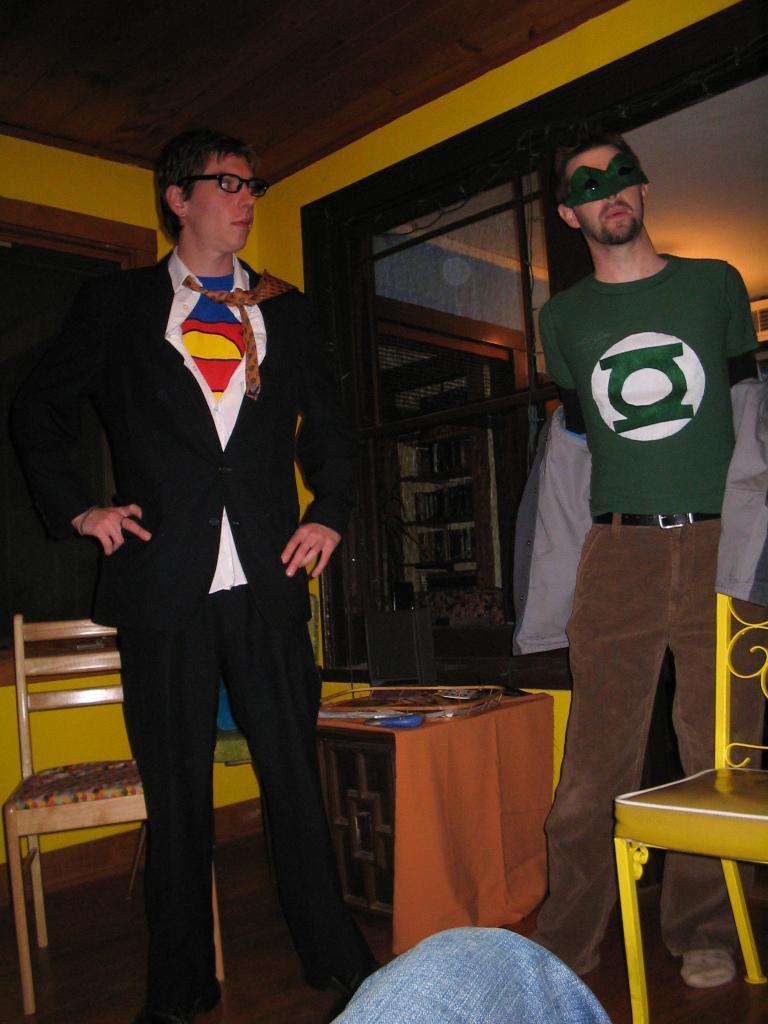Could you give a brief overview of what you see in this image? There are two persons standing in this image. One person at the left side is wearing a suit and tie, spectacles. Person at the right side is wearing a green shirt, brown pant and mask to his eyes. There is a table in between the persons. Back to this person there is a chair. Bottom of the image there is a person wearing a jeans. 